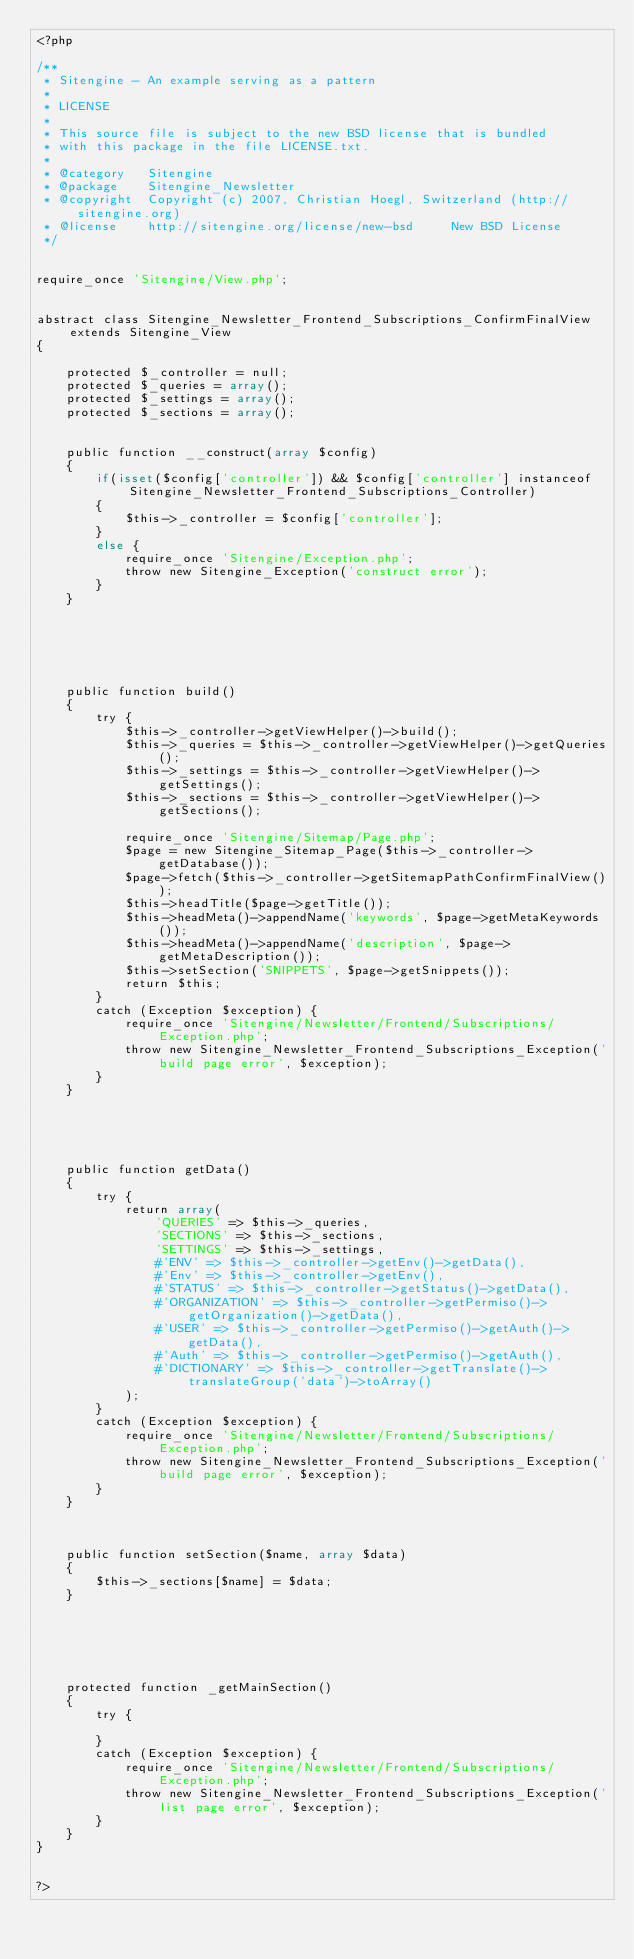<code> <loc_0><loc_0><loc_500><loc_500><_PHP_><?php

/**
 * Sitengine - An example serving as a pattern
 *
 * LICENSE
 *
 * This source file is subject to the new BSD license that is bundled
 * with this package in the file LICENSE.txt.
 *
 * @category   Sitengine
 * @package    Sitengine_Newsletter
 * @copyright  Copyright (c) 2007, Christian Hoegl, Switzerland (http://sitengine.org)
 * @license    http://sitengine.org/license/new-bsd     New BSD License
 */


require_once 'Sitengine/View.php';


abstract class Sitengine_Newsletter_Frontend_Subscriptions_ConfirmFinalView extends Sitengine_View
{
    
	protected $_controller = null;
    protected $_queries = array();
    protected $_settings = array();
    protected $_sections = array();
    
    
    public function __construct(array $config)
    {
    	if(isset($config['controller']) && $config['controller'] instanceof Sitengine_Newsletter_Frontend_Subscriptions_Controller)
    	{
    		$this->_controller = $config['controller'];
    	}
    	else {
    		require_once 'Sitengine/Exception.php';
        	throw new Sitengine_Exception('construct error');
    	}
    }
    
    
    
    
    
    
    public function build()
    {
        try {
            $this->_controller->getViewHelper()->build();
			$this->_queries = $this->_controller->getViewHelper()->getQueries();
            $this->_settings = $this->_controller->getViewHelper()->getSettings();
            $this->_sections = $this->_controller->getViewHelper()->getSections();
            
            require_once 'Sitengine/Sitemap/Page.php';
        	$page = new Sitengine_Sitemap_Page($this->_controller->getDatabase());
			$page->fetch($this->_controller->getSitemapPathConfirmFinalView());
			$this->headTitle($page->getTitle());
			$this->headMeta()->appendName('keywords', $page->getMetaKeywords());
			$this->headMeta()->appendName('description', $page->getMetaDescription());
            $this->setSection('SNIPPETS', $page->getSnippets());
            return $this;
        }
        catch (Exception $exception) {
        	require_once 'Sitengine/Newsletter/Frontend/Subscriptions/Exception.php';
        	throw new Sitengine_Newsletter_Frontend_Subscriptions_Exception('build page error', $exception);
        }
    }
    
    
    
    
    
    public function getData()
    {
    	try {
			return array(
				'QUERIES' => $this->_queries,
				'SECTIONS' => $this->_sections,
				'SETTINGS' => $this->_settings,
				#'ENV' => $this->_controller->getEnv()->getData(),
				#'Env' => $this->_controller->getEnv(),
				#'STATUS' => $this->_controller->getStatus()->getData(),
				#'ORGANIZATION' => $this->_controller->getPermiso()->getOrganization()->getData(),
				#'USER' => $this->_controller->getPermiso()->getAuth()->getData(),
				#'Auth' => $this->_controller->getPermiso()->getAuth(),
				#'DICTIONARY' => $this->_controller->getTranslate()->translateGroup('data')->toArray()
			);
		}
        catch (Exception $exception) {
			require_once 'Sitengine/Newsletter/Frontend/Subscriptions/Exception.php';
			throw new Sitengine_Newsletter_Frontend_Subscriptions_Exception('build page error', $exception);
		}
    }
    
    
    
    public function setSection($name, array $data)
    {
        $this->_sections[$name] = $data;
    }
    
    
    
    
    
    
    protected function _getMainSection()
    {
        try {
        	
        }
        catch (Exception $exception) {
			require_once 'Sitengine/Newsletter/Frontend/Subscriptions/Exception.php';
			throw new Sitengine_Newsletter_Frontend_Subscriptions_Exception('list page error', $exception);
		}
    }
}


?></code> 